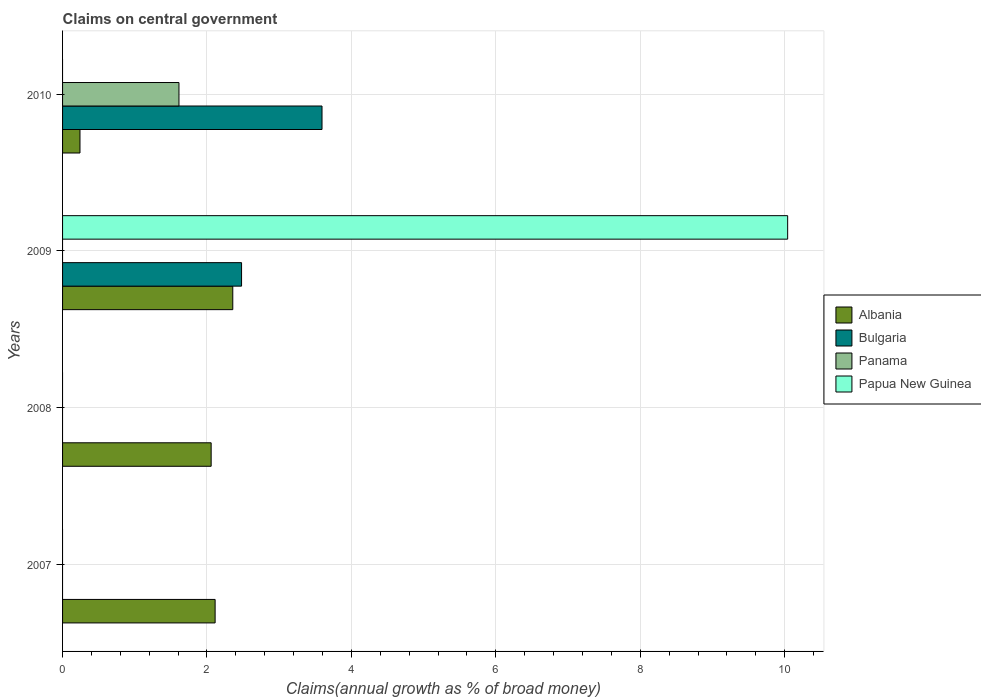Are the number of bars on each tick of the Y-axis equal?
Offer a terse response. No. How many bars are there on the 1st tick from the top?
Provide a succinct answer. 3. What is the label of the 3rd group of bars from the top?
Offer a terse response. 2008. In how many cases, is the number of bars for a given year not equal to the number of legend labels?
Provide a succinct answer. 4. What is the percentage of broad money claimed on centeral government in Panama in 2009?
Keep it short and to the point. 0. Across all years, what is the maximum percentage of broad money claimed on centeral government in Papua New Guinea?
Your answer should be very brief. 10.04. Across all years, what is the minimum percentage of broad money claimed on centeral government in Albania?
Your answer should be very brief. 0.24. What is the total percentage of broad money claimed on centeral government in Papua New Guinea in the graph?
Offer a terse response. 10.04. What is the difference between the percentage of broad money claimed on centeral government in Albania in 2008 and that in 2009?
Provide a succinct answer. -0.3. What is the difference between the percentage of broad money claimed on centeral government in Papua New Guinea in 2010 and the percentage of broad money claimed on centeral government in Albania in 2007?
Make the answer very short. -2.11. What is the average percentage of broad money claimed on centeral government in Albania per year?
Your answer should be compact. 1.69. In the year 2009, what is the difference between the percentage of broad money claimed on centeral government in Bulgaria and percentage of broad money claimed on centeral government in Papua New Guinea?
Your answer should be compact. -7.56. What is the ratio of the percentage of broad money claimed on centeral government in Albania in 2008 to that in 2010?
Your answer should be very brief. 8.53. Is the percentage of broad money claimed on centeral government in Albania in 2007 less than that in 2010?
Your answer should be compact. No. What is the difference between the highest and the second highest percentage of broad money claimed on centeral government in Albania?
Offer a terse response. 0.24. What is the difference between the highest and the lowest percentage of broad money claimed on centeral government in Papua New Guinea?
Make the answer very short. 10.04. Are all the bars in the graph horizontal?
Ensure brevity in your answer.  Yes. How many years are there in the graph?
Your answer should be compact. 4. What is the difference between two consecutive major ticks on the X-axis?
Your answer should be compact. 2. Are the values on the major ticks of X-axis written in scientific E-notation?
Give a very brief answer. No. Does the graph contain any zero values?
Give a very brief answer. Yes. Does the graph contain grids?
Provide a short and direct response. Yes. Where does the legend appear in the graph?
Your answer should be very brief. Center right. How many legend labels are there?
Ensure brevity in your answer.  4. What is the title of the graph?
Give a very brief answer. Claims on central government. What is the label or title of the X-axis?
Provide a short and direct response. Claims(annual growth as % of broad money). What is the label or title of the Y-axis?
Offer a terse response. Years. What is the Claims(annual growth as % of broad money) of Albania in 2007?
Provide a short and direct response. 2.11. What is the Claims(annual growth as % of broad money) in Bulgaria in 2007?
Make the answer very short. 0. What is the Claims(annual growth as % of broad money) in Panama in 2007?
Your answer should be very brief. 0. What is the Claims(annual growth as % of broad money) in Papua New Guinea in 2007?
Your answer should be compact. 0. What is the Claims(annual growth as % of broad money) in Albania in 2008?
Make the answer very short. 2.06. What is the Claims(annual growth as % of broad money) of Panama in 2008?
Your response must be concise. 0. What is the Claims(annual growth as % of broad money) in Papua New Guinea in 2008?
Provide a succinct answer. 0. What is the Claims(annual growth as % of broad money) in Albania in 2009?
Your answer should be very brief. 2.36. What is the Claims(annual growth as % of broad money) in Bulgaria in 2009?
Provide a short and direct response. 2.48. What is the Claims(annual growth as % of broad money) of Panama in 2009?
Give a very brief answer. 0. What is the Claims(annual growth as % of broad money) of Papua New Guinea in 2009?
Give a very brief answer. 10.04. What is the Claims(annual growth as % of broad money) in Albania in 2010?
Provide a short and direct response. 0.24. What is the Claims(annual growth as % of broad money) in Bulgaria in 2010?
Make the answer very short. 3.59. What is the Claims(annual growth as % of broad money) of Panama in 2010?
Your response must be concise. 1.61. What is the Claims(annual growth as % of broad money) in Papua New Guinea in 2010?
Your response must be concise. 0. Across all years, what is the maximum Claims(annual growth as % of broad money) of Albania?
Your response must be concise. 2.36. Across all years, what is the maximum Claims(annual growth as % of broad money) of Bulgaria?
Offer a terse response. 3.59. Across all years, what is the maximum Claims(annual growth as % of broad money) in Panama?
Offer a terse response. 1.61. Across all years, what is the maximum Claims(annual growth as % of broad money) of Papua New Guinea?
Keep it short and to the point. 10.04. Across all years, what is the minimum Claims(annual growth as % of broad money) in Albania?
Give a very brief answer. 0.24. Across all years, what is the minimum Claims(annual growth as % of broad money) in Bulgaria?
Offer a terse response. 0. Across all years, what is the minimum Claims(annual growth as % of broad money) in Panama?
Make the answer very short. 0. What is the total Claims(annual growth as % of broad money) of Albania in the graph?
Offer a very short reply. 6.77. What is the total Claims(annual growth as % of broad money) of Bulgaria in the graph?
Keep it short and to the point. 6.07. What is the total Claims(annual growth as % of broad money) of Panama in the graph?
Give a very brief answer. 1.61. What is the total Claims(annual growth as % of broad money) of Papua New Guinea in the graph?
Your answer should be compact. 10.04. What is the difference between the Claims(annual growth as % of broad money) in Albania in 2007 and that in 2008?
Provide a succinct answer. 0.06. What is the difference between the Claims(annual growth as % of broad money) of Albania in 2007 and that in 2009?
Offer a terse response. -0.24. What is the difference between the Claims(annual growth as % of broad money) of Albania in 2007 and that in 2010?
Give a very brief answer. 1.87. What is the difference between the Claims(annual growth as % of broad money) of Albania in 2008 and that in 2009?
Offer a very short reply. -0.3. What is the difference between the Claims(annual growth as % of broad money) in Albania in 2008 and that in 2010?
Keep it short and to the point. 1.82. What is the difference between the Claims(annual growth as % of broad money) of Albania in 2009 and that in 2010?
Provide a succinct answer. 2.12. What is the difference between the Claims(annual growth as % of broad money) of Bulgaria in 2009 and that in 2010?
Keep it short and to the point. -1.11. What is the difference between the Claims(annual growth as % of broad money) in Albania in 2007 and the Claims(annual growth as % of broad money) in Bulgaria in 2009?
Give a very brief answer. -0.37. What is the difference between the Claims(annual growth as % of broad money) in Albania in 2007 and the Claims(annual growth as % of broad money) in Papua New Guinea in 2009?
Your answer should be very brief. -7.93. What is the difference between the Claims(annual growth as % of broad money) of Albania in 2007 and the Claims(annual growth as % of broad money) of Bulgaria in 2010?
Give a very brief answer. -1.48. What is the difference between the Claims(annual growth as % of broad money) in Albania in 2007 and the Claims(annual growth as % of broad money) in Panama in 2010?
Your response must be concise. 0.5. What is the difference between the Claims(annual growth as % of broad money) in Albania in 2008 and the Claims(annual growth as % of broad money) in Bulgaria in 2009?
Offer a terse response. -0.42. What is the difference between the Claims(annual growth as % of broad money) of Albania in 2008 and the Claims(annual growth as % of broad money) of Papua New Guinea in 2009?
Offer a very short reply. -7.98. What is the difference between the Claims(annual growth as % of broad money) in Albania in 2008 and the Claims(annual growth as % of broad money) in Bulgaria in 2010?
Your answer should be very brief. -1.54. What is the difference between the Claims(annual growth as % of broad money) in Albania in 2008 and the Claims(annual growth as % of broad money) in Panama in 2010?
Ensure brevity in your answer.  0.45. What is the difference between the Claims(annual growth as % of broad money) in Albania in 2009 and the Claims(annual growth as % of broad money) in Bulgaria in 2010?
Your answer should be very brief. -1.24. What is the difference between the Claims(annual growth as % of broad money) in Albania in 2009 and the Claims(annual growth as % of broad money) in Panama in 2010?
Make the answer very short. 0.75. What is the difference between the Claims(annual growth as % of broad money) in Bulgaria in 2009 and the Claims(annual growth as % of broad money) in Panama in 2010?
Make the answer very short. 0.87. What is the average Claims(annual growth as % of broad money) in Albania per year?
Your response must be concise. 1.69. What is the average Claims(annual growth as % of broad money) in Bulgaria per year?
Offer a terse response. 1.52. What is the average Claims(annual growth as % of broad money) in Panama per year?
Ensure brevity in your answer.  0.4. What is the average Claims(annual growth as % of broad money) of Papua New Guinea per year?
Keep it short and to the point. 2.51. In the year 2009, what is the difference between the Claims(annual growth as % of broad money) of Albania and Claims(annual growth as % of broad money) of Bulgaria?
Provide a succinct answer. -0.12. In the year 2009, what is the difference between the Claims(annual growth as % of broad money) of Albania and Claims(annual growth as % of broad money) of Papua New Guinea?
Make the answer very short. -7.68. In the year 2009, what is the difference between the Claims(annual growth as % of broad money) in Bulgaria and Claims(annual growth as % of broad money) in Papua New Guinea?
Keep it short and to the point. -7.56. In the year 2010, what is the difference between the Claims(annual growth as % of broad money) of Albania and Claims(annual growth as % of broad money) of Bulgaria?
Make the answer very short. -3.35. In the year 2010, what is the difference between the Claims(annual growth as % of broad money) in Albania and Claims(annual growth as % of broad money) in Panama?
Your answer should be very brief. -1.37. In the year 2010, what is the difference between the Claims(annual growth as % of broad money) of Bulgaria and Claims(annual growth as % of broad money) of Panama?
Your answer should be compact. 1.98. What is the ratio of the Claims(annual growth as % of broad money) of Albania in 2007 to that in 2008?
Ensure brevity in your answer.  1.03. What is the ratio of the Claims(annual growth as % of broad money) in Albania in 2007 to that in 2009?
Your response must be concise. 0.9. What is the ratio of the Claims(annual growth as % of broad money) of Albania in 2007 to that in 2010?
Keep it short and to the point. 8.76. What is the ratio of the Claims(annual growth as % of broad money) in Albania in 2008 to that in 2009?
Provide a succinct answer. 0.87. What is the ratio of the Claims(annual growth as % of broad money) in Albania in 2008 to that in 2010?
Your response must be concise. 8.53. What is the ratio of the Claims(annual growth as % of broad money) of Albania in 2009 to that in 2010?
Offer a terse response. 9.77. What is the ratio of the Claims(annual growth as % of broad money) in Bulgaria in 2009 to that in 2010?
Your answer should be compact. 0.69. What is the difference between the highest and the second highest Claims(annual growth as % of broad money) of Albania?
Keep it short and to the point. 0.24. What is the difference between the highest and the lowest Claims(annual growth as % of broad money) in Albania?
Offer a very short reply. 2.12. What is the difference between the highest and the lowest Claims(annual growth as % of broad money) of Bulgaria?
Ensure brevity in your answer.  3.59. What is the difference between the highest and the lowest Claims(annual growth as % of broad money) in Panama?
Ensure brevity in your answer.  1.61. What is the difference between the highest and the lowest Claims(annual growth as % of broad money) of Papua New Guinea?
Ensure brevity in your answer.  10.04. 